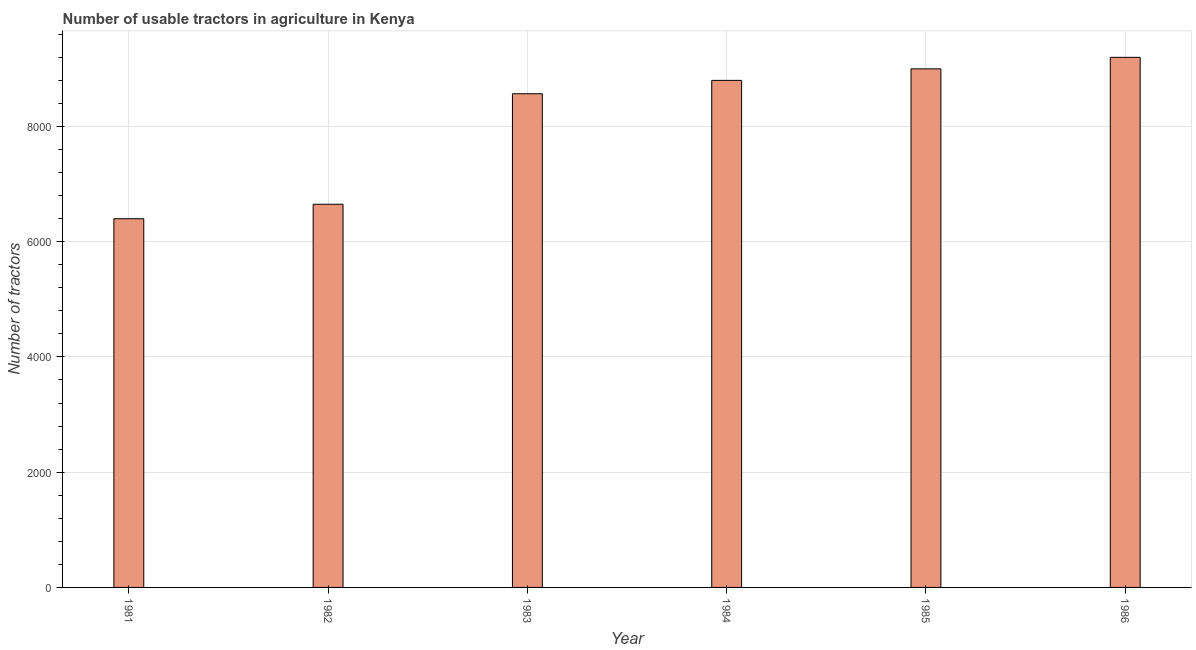What is the title of the graph?
Make the answer very short. Number of usable tractors in agriculture in Kenya. What is the label or title of the Y-axis?
Make the answer very short. Number of tractors. What is the number of tractors in 1986?
Ensure brevity in your answer.  9200. Across all years, what is the maximum number of tractors?
Offer a terse response. 9200. Across all years, what is the minimum number of tractors?
Make the answer very short. 6399. What is the sum of the number of tractors?
Give a very brief answer. 4.86e+04. What is the difference between the number of tractors in 1982 and 1986?
Provide a succinct answer. -2550. What is the average number of tractors per year?
Offer a very short reply. 8102. What is the median number of tractors?
Ensure brevity in your answer.  8684. What is the ratio of the number of tractors in 1981 to that in 1985?
Your answer should be compact. 0.71. Is the number of tractors in 1984 less than that in 1985?
Ensure brevity in your answer.  Yes. What is the difference between the highest and the lowest number of tractors?
Give a very brief answer. 2801. In how many years, is the number of tractors greater than the average number of tractors taken over all years?
Provide a succinct answer. 4. Are all the bars in the graph horizontal?
Make the answer very short. No. What is the difference between two consecutive major ticks on the Y-axis?
Provide a short and direct response. 2000. Are the values on the major ticks of Y-axis written in scientific E-notation?
Provide a succinct answer. No. What is the Number of tractors of 1981?
Make the answer very short. 6399. What is the Number of tractors of 1982?
Give a very brief answer. 6650. What is the Number of tractors in 1983?
Your answer should be compact. 8568. What is the Number of tractors in 1984?
Your response must be concise. 8800. What is the Number of tractors of 1985?
Ensure brevity in your answer.  9000. What is the Number of tractors of 1986?
Offer a very short reply. 9200. What is the difference between the Number of tractors in 1981 and 1982?
Your answer should be very brief. -251. What is the difference between the Number of tractors in 1981 and 1983?
Keep it short and to the point. -2169. What is the difference between the Number of tractors in 1981 and 1984?
Provide a short and direct response. -2401. What is the difference between the Number of tractors in 1981 and 1985?
Your answer should be very brief. -2601. What is the difference between the Number of tractors in 1981 and 1986?
Provide a short and direct response. -2801. What is the difference between the Number of tractors in 1982 and 1983?
Keep it short and to the point. -1918. What is the difference between the Number of tractors in 1982 and 1984?
Make the answer very short. -2150. What is the difference between the Number of tractors in 1982 and 1985?
Offer a terse response. -2350. What is the difference between the Number of tractors in 1982 and 1986?
Your answer should be compact. -2550. What is the difference between the Number of tractors in 1983 and 1984?
Provide a succinct answer. -232. What is the difference between the Number of tractors in 1983 and 1985?
Provide a short and direct response. -432. What is the difference between the Number of tractors in 1983 and 1986?
Offer a very short reply. -632. What is the difference between the Number of tractors in 1984 and 1985?
Provide a succinct answer. -200. What is the difference between the Number of tractors in 1984 and 1986?
Provide a succinct answer. -400. What is the difference between the Number of tractors in 1985 and 1986?
Offer a very short reply. -200. What is the ratio of the Number of tractors in 1981 to that in 1983?
Keep it short and to the point. 0.75. What is the ratio of the Number of tractors in 1981 to that in 1984?
Your answer should be very brief. 0.73. What is the ratio of the Number of tractors in 1981 to that in 1985?
Give a very brief answer. 0.71. What is the ratio of the Number of tractors in 1981 to that in 1986?
Your answer should be compact. 0.7. What is the ratio of the Number of tractors in 1982 to that in 1983?
Ensure brevity in your answer.  0.78. What is the ratio of the Number of tractors in 1982 to that in 1984?
Make the answer very short. 0.76. What is the ratio of the Number of tractors in 1982 to that in 1985?
Offer a very short reply. 0.74. What is the ratio of the Number of tractors in 1982 to that in 1986?
Ensure brevity in your answer.  0.72. What is the ratio of the Number of tractors in 1983 to that in 1984?
Offer a terse response. 0.97. What is the ratio of the Number of tractors in 1983 to that in 1985?
Keep it short and to the point. 0.95. What is the ratio of the Number of tractors in 1984 to that in 1985?
Your response must be concise. 0.98. What is the ratio of the Number of tractors in 1984 to that in 1986?
Provide a succinct answer. 0.96. What is the ratio of the Number of tractors in 1985 to that in 1986?
Provide a short and direct response. 0.98. 